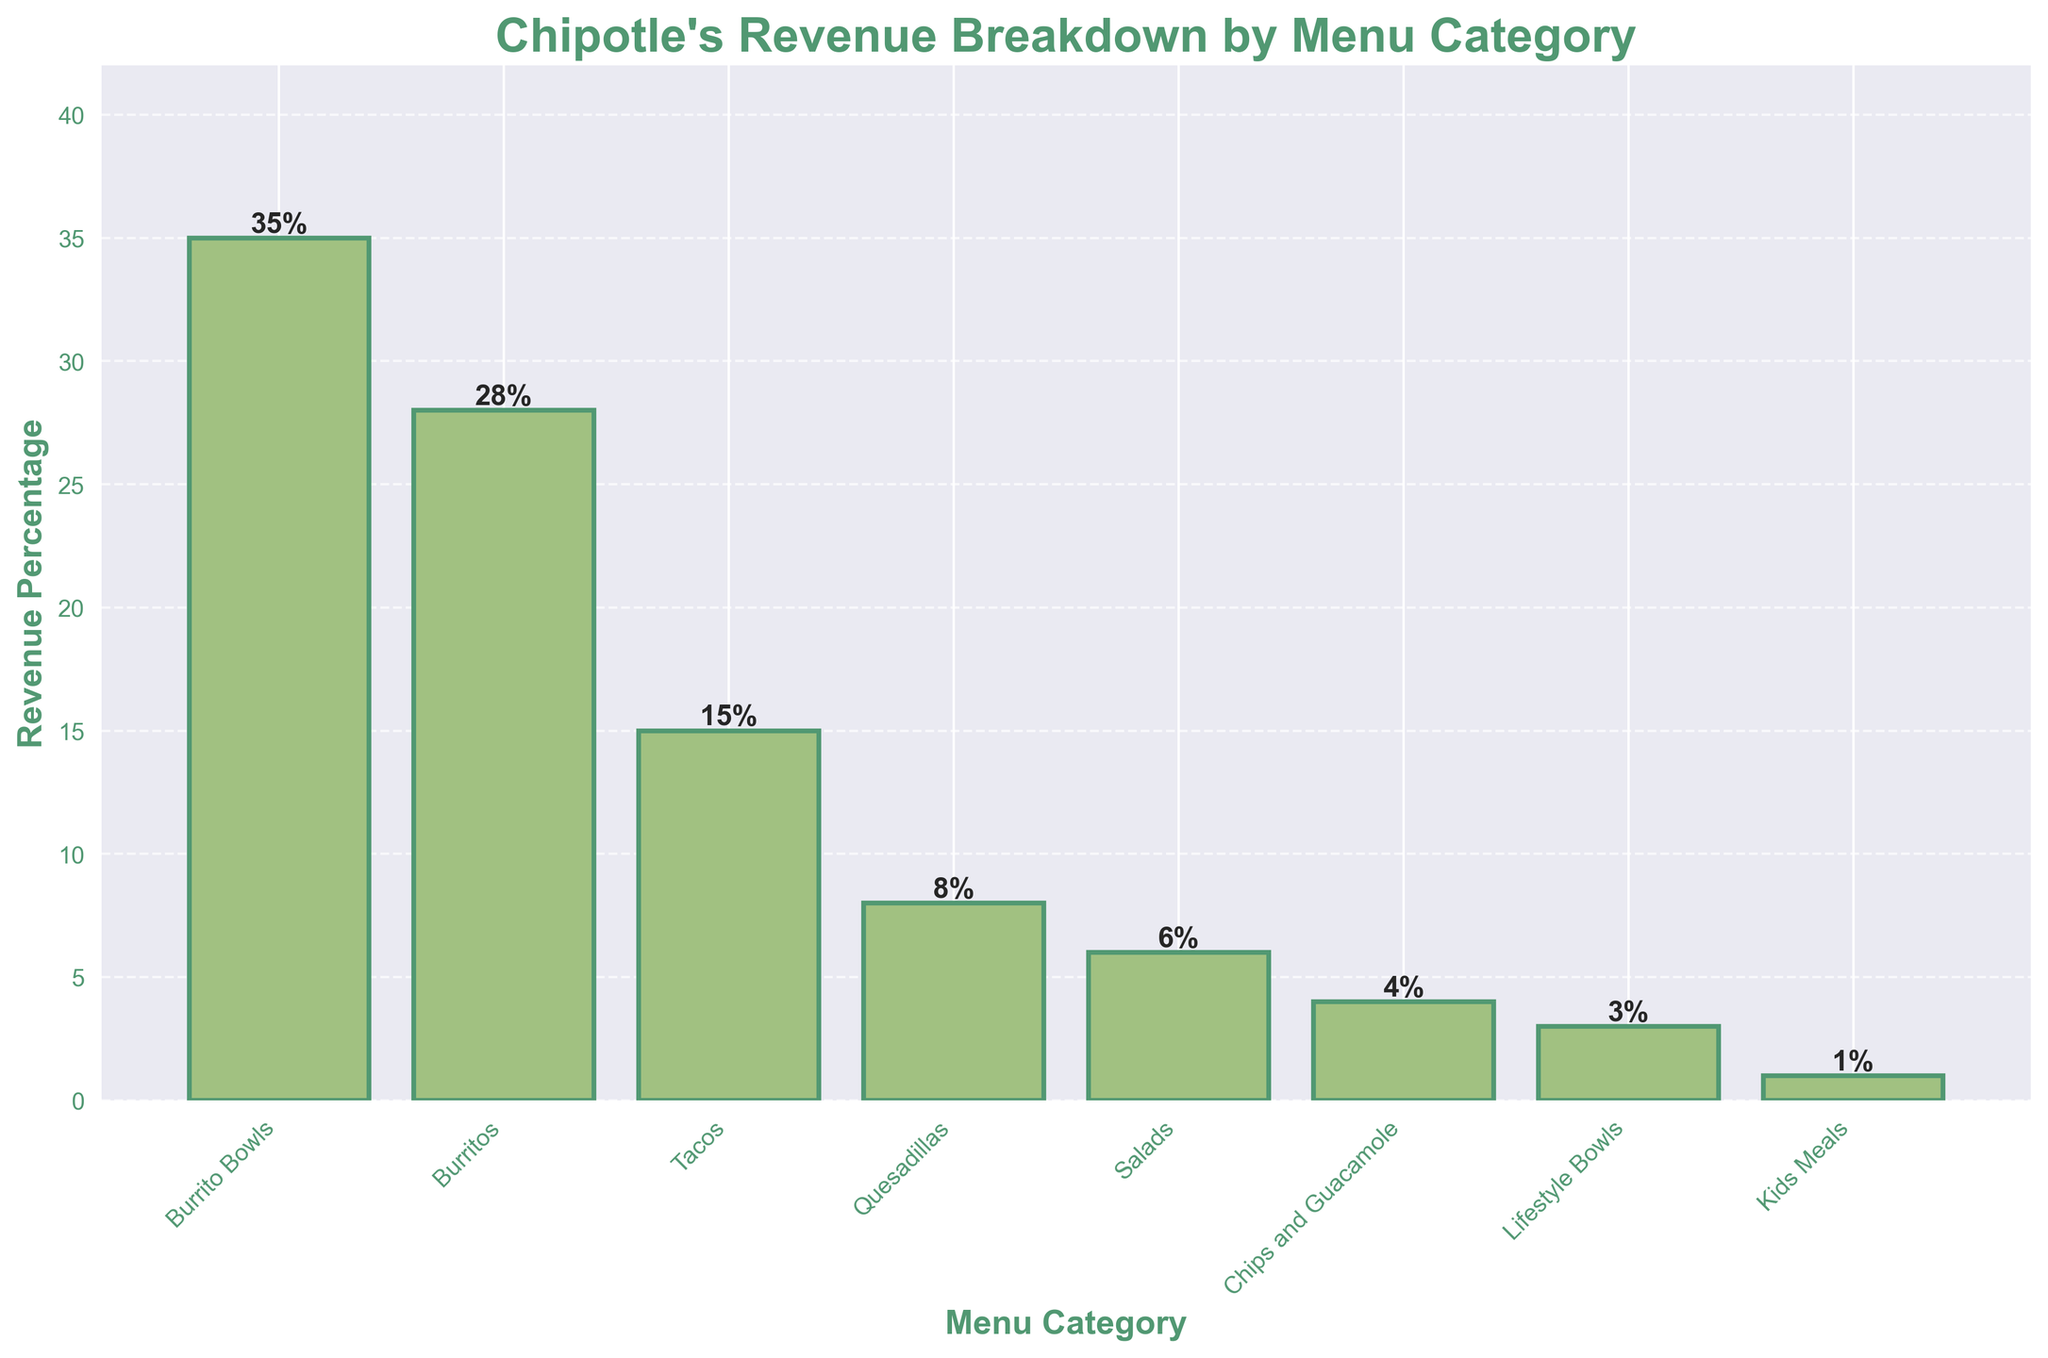Which menu category contributes the most to Chipotle's revenue? By looking at the heights of the bars, the "Burrito Bowls" category has the highest value at 35%
Answer: Burrito Bowls What is the combined revenue percentage of Burritos and Tacos? The revenue percentages for Burritos and Tacos are 28% and 15% respectively. Adding them together: 28% + 15% = 43%
Answer: 43% By how much is the revenue percentage of Quesadillas higher than that of Lifestyle Bowls? The Quesadillas category has a revenue percentage of 8%, while the Lifestyle Bowls category has 3%. The difference is calculated as: 8% - 3% = 5%
Answer: 5% Which category has the lowest revenue percentage, and what is that percentage? By examining the bar chart, the "Kids Meals" category has the lowest revenue percentage at 1%
Answer: Kids Meals, 1% How does the revenue percentage of Salads compare to that of Chips and Guacamole? The bar heights indicate that Salads have a revenue percentage of 6%, while Chips and Guacamole have 4%. Therefore, Salads have a higher percentage than Chips and Guacamole.
Answer: Salads > Chips and Guacamole What is the combined revenue percentage of the three least contributing categories? The three least contributing categories are Chips and Guacamole (4%), Lifestyle Bowls (3%), and Kids Meals (1%). Adding them together: 4% + 3% + 1% = 8%
Answer: 8% Which is greater: the revenue percentage from Burrito Bowls or the combined revenue from Quesadillas and Tacos? Burrito Bowls have a revenue percentage of 35%. The combined revenue for Quesadillas and Tacos is: 8% + 15% = 23%. Therefore, Burrito Bowls have a higher revenue percentage than the combined total of Quesadillas and Tacos.
Answer: Burrito Bowls What fraction of the total revenue does the Burritos category represent? The Burritos category has a revenue percentage of 28%. Since the percentage is out of 100%, the fraction is 28/100 or simplified as 7/25
Answer: 7/25 Is the total revenue percentage of Salads and Kids Meals higher than the revenue of one of the top two categories? The total revenue of Salads and Kids Meals is 6% + 1% = 7%. Comparing this to the top two categories, Burrito Bowls (35%) and Burritos (28%), 7% is not higher than either of the top two categories' revenue percentages.
Answer: No What is the average revenue percentage of Burrito Bowls, Burritos, and Tacos? To find the average, add the percentages of Burrito Bowls (35%), Burritos (28%), and Tacos (15%) and divide by the number of categories: (35% + 28% + 15%) / 3 = 78% / 3 = 26%
Answer: 26% 